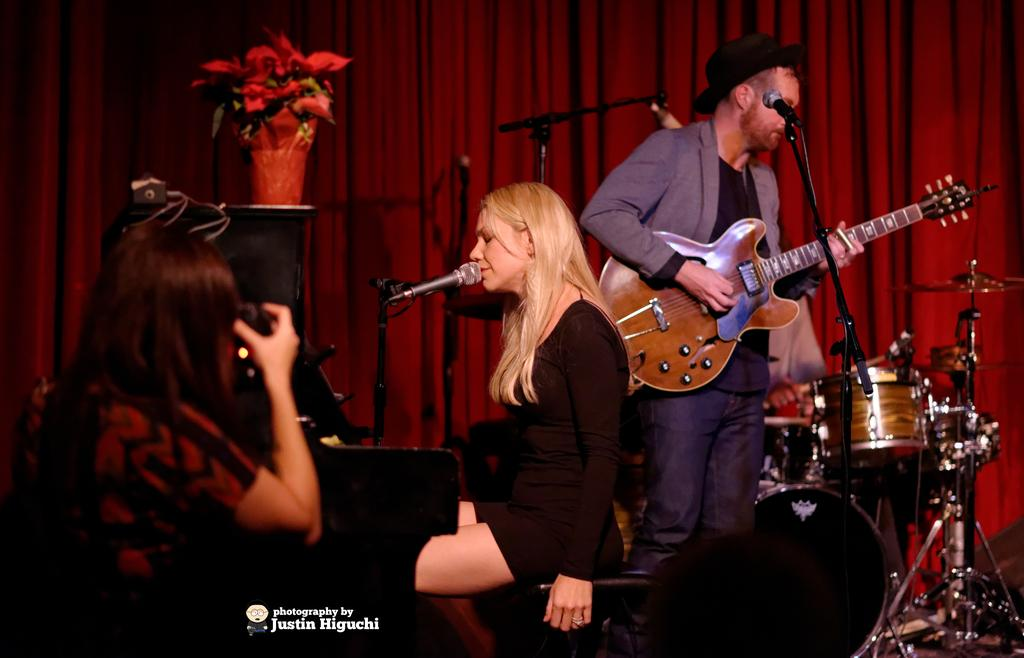What is the woman doing in the image? The woman is singing on a microphone. What is the man doing in the image? The man is playing a guitar. Can you describe the activity taking place in the image? The woman and the man are performing together, with the woman singing and the man playing the guitar. What type of pig can be seen in the image? There is no pig present in the image. 